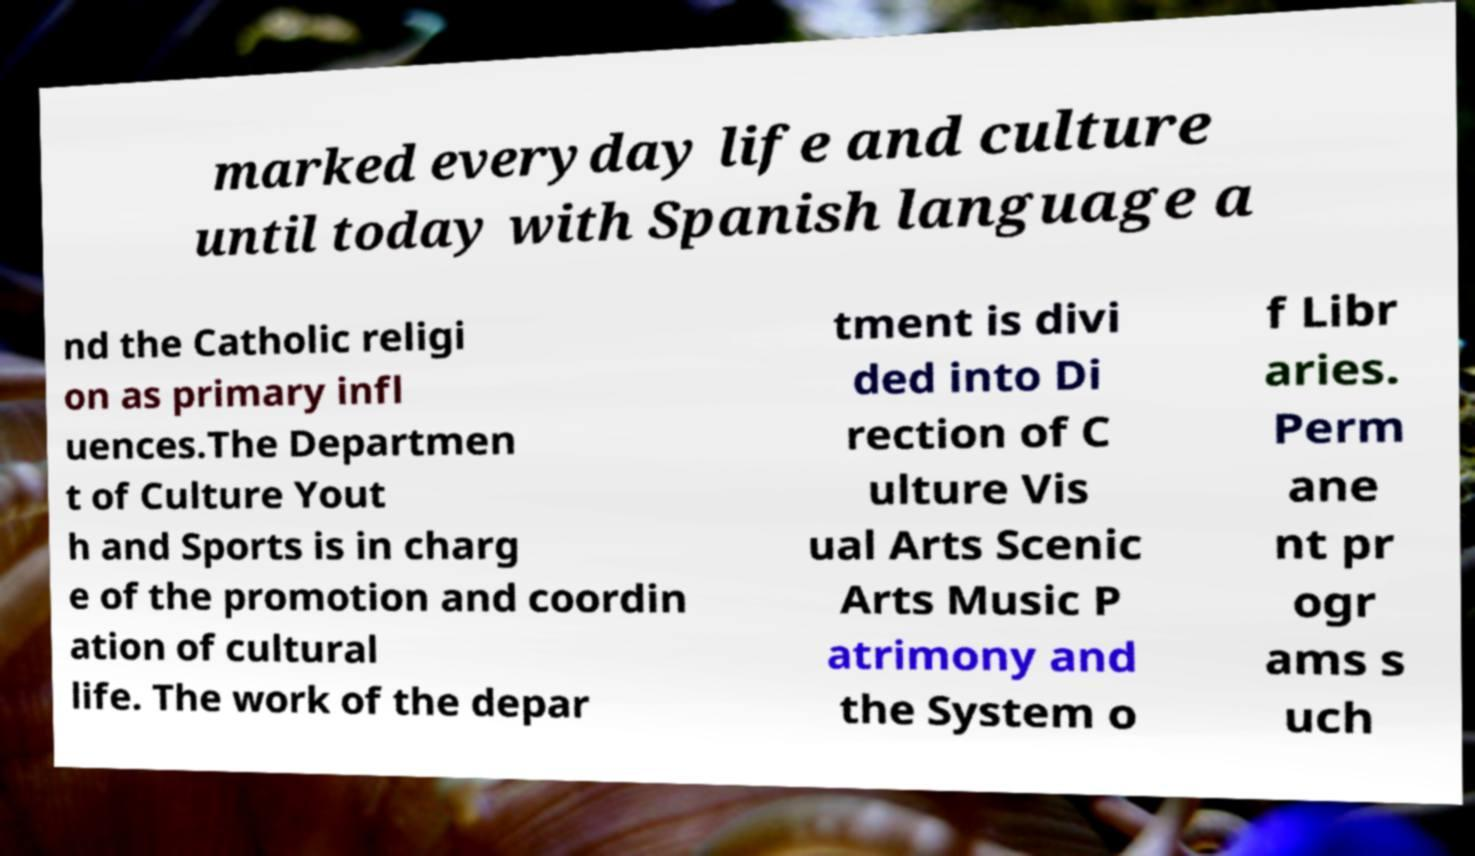Can you accurately transcribe the text from the provided image for me? marked everyday life and culture until today with Spanish language a nd the Catholic religi on as primary infl uences.The Departmen t of Culture Yout h and Sports is in charg e of the promotion and coordin ation of cultural life. The work of the depar tment is divi ded into Di rection of C ulture Vis ual Arts Scenic Arts Music P atrimony and the System o f Libr aries. Perm ane nt pr ogr ams s uch 